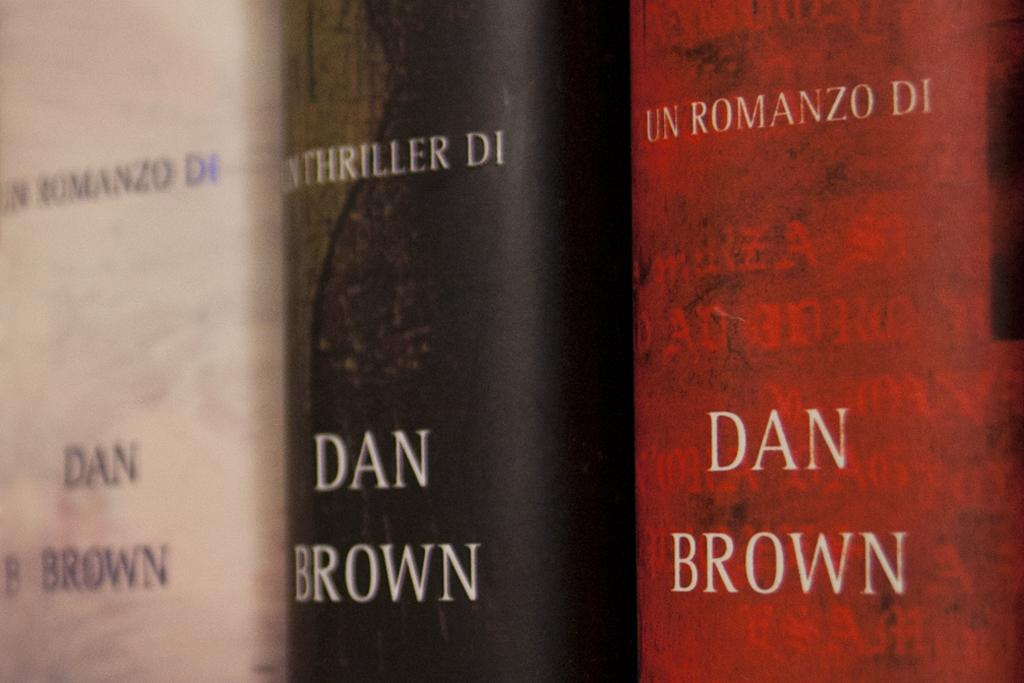<image>
Relay a brief, clear account of the picture shown. Three Dan brown thriller books in a line. 